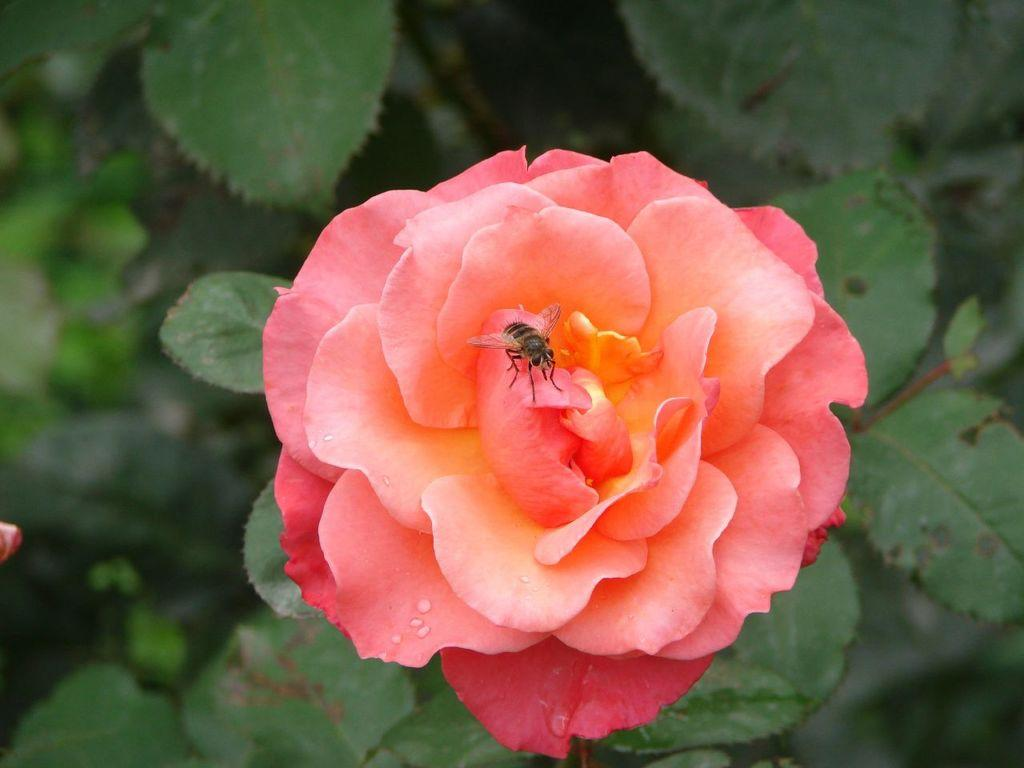What is present in the image? There is a fly in the image. Where is the fly located? The fly is on a flower. What type of government is depicted in the image? There is no government depicted in the image; it features a fly on a flower. How does the fly maintain its grip on the flower in the image? The image does not show the fly's grip on the flower, so it cannot be determined from the image. 